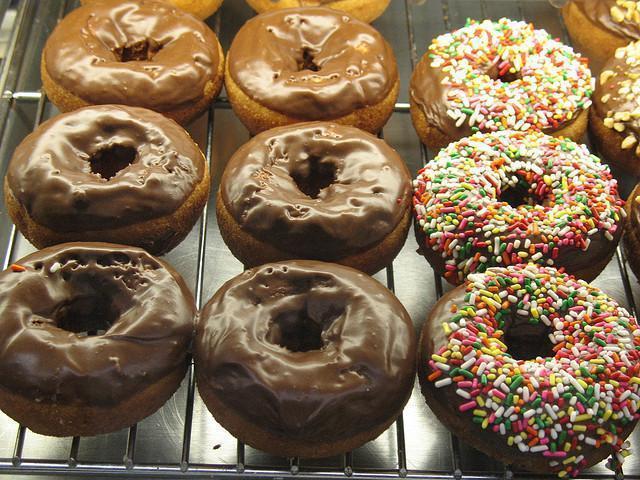These items are usually eaten for what?
Indicate the correct response by choosing from the four available options to answer the question.
Options: Lunch, snack, fancy wedding, dinner. Snack. 